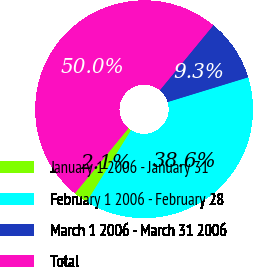<chart> <loc_0><loc_0><loc_500><loc_500><pie_chart><fcel>January 1 2006 - January 31<fcel>February 1 2006 - February 28<fcel>March 1 2006 - March 31 2006<fcel>Total<nl><fcel>2.14%<fcel>38.57%<fcel>9.29%<fcel>50.0%<nl></chart> 